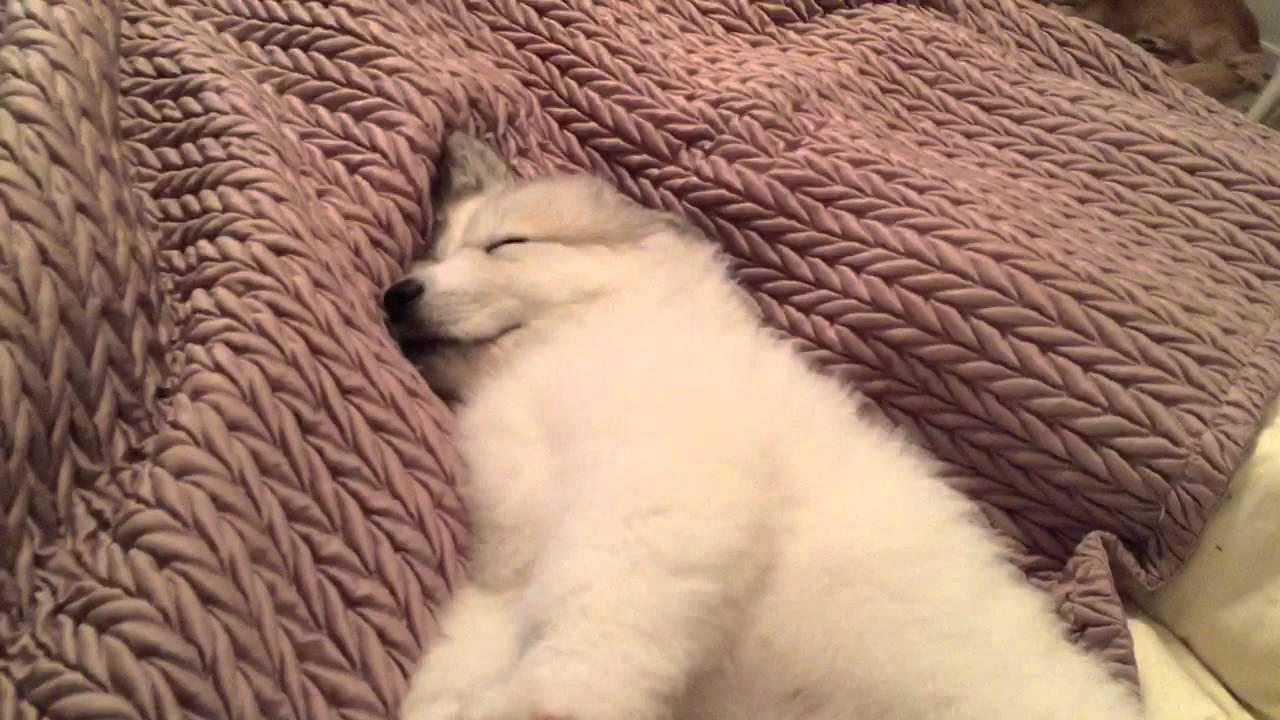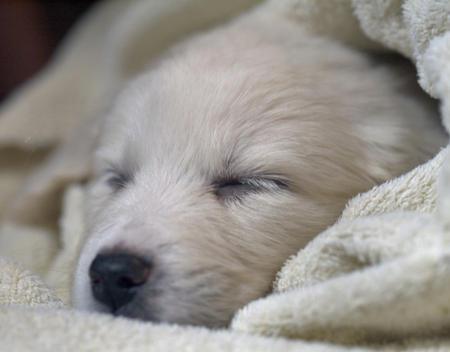The first image is the image on the left, the second image is the image on the right. Given the left and right images, does the statement "A bright red plush item is next to the head of the dog in one image." hold true? Answer yes or no. No. The first image is the image on the left, the second image is the image on the right. Assess this claim about the two images: "The dog in only one of the images has its eyes open.". Correct or not? Answer yes or no. No. 